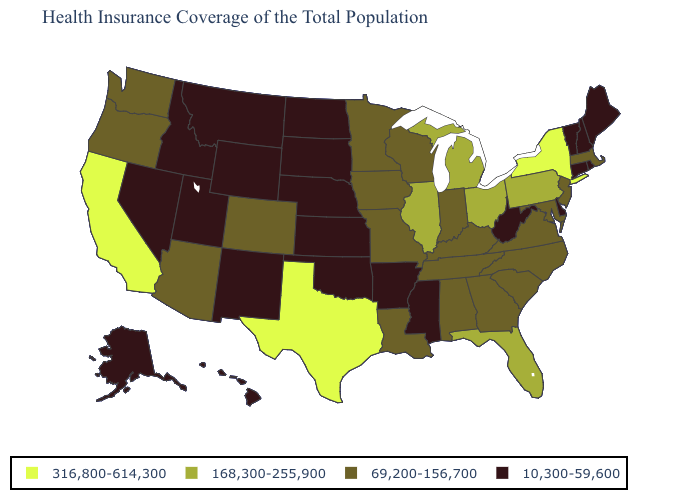What is the value of Indiana?
Be succinct. 69,200-156,700. What is the value of Georgia?
Be succinct. 69,200-156,700. Among the states that border North Dakota , does Montana have the lowest value?
Be succinct. Yes. Name the states that have a value in the range 10,300-59,600?
Keep it brief. Alaska, Arkansas, Connecticut, Delaware, Hawaii, Idaho, Kansas, Maine, Mississippi, Montana, Nebraska, Nevada, New Hampshire, New Mexico, North Dakota, Oklahoma, Rhode Island, South Dakota, Utah, Vermont, West Virginia, Wyoming. What is the value of Montana?
Write a very short answer. 10,300-59,600. Among the states that border Rhode Island , does Connecticut have the highest value?
Write a very short answer. No. Does Georgia have the same value as Nevada?
Concise answer only. No. Among the states that border Wyoming , which have the lowest value?
Short answer required. Idaho, Montana, Nebraska, South Dakota, Utah. Does Ohio have the highest value in the MidWest?
Keep it brief. Yes. Does Hawaii have a higher value than Rhode Island?
Write a very short answer. No. Name the states that have a value in the range 316,800-614,300?
Give a very brief answer. California, New York, Texas. What is the value of Louisiana?
Write a very short answer. 69,200-156,700. What is the value of Wyoming?
Concise answer only. 10,300-59,600. Does the first symbol in the legend represent the smallest category?
Answer briefly. No. Does Iowa have the lowest value in the USA?
Keep it brief. No. 